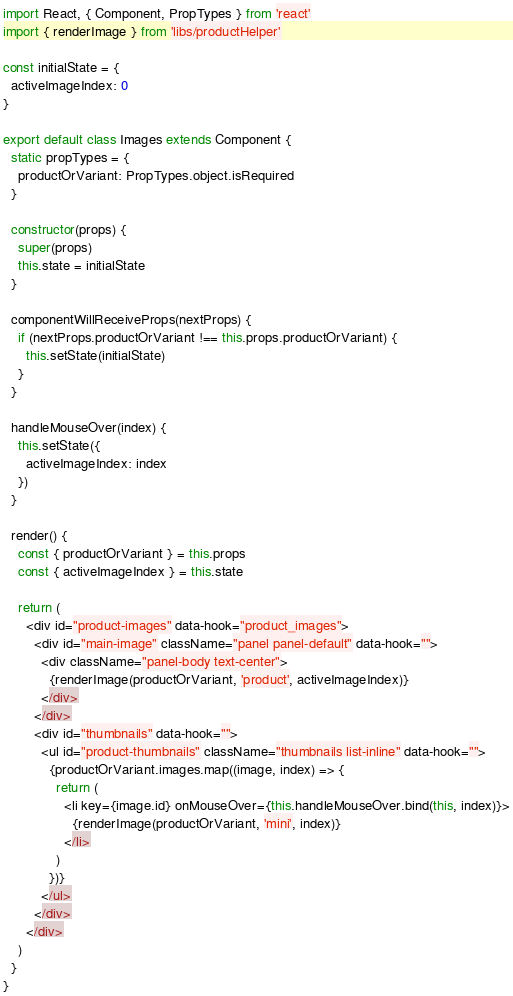<code> <loc_0><loc_0><loc_500><loc_500><_JavaScript_>import React, { Component, PropTypes } from 'react'
import { renderImage } from 'libs/productHelper'

const initialState = {
  activeImageIndex: 0
}

export default class Images extends Component {
  static propTypes = {
    productOrVariant: PropTypes.object.isRequired
  }

  constructor(props) {
    super(props)
    this.state = initialState
  }

  componentWillReceiveProps(nextProps) {
    if (nextProps.productOrVariant !== this.props.productOrVariant) {
      this.setState(initialState)
    }
  }

  handleMouseOver(index) {
    this.setState({
      activeImageIndex: index
    })
  }

  render() {
    const { productOrVariant } = this.props
    const { activeImageIndex } = this.state

    return (
      <div id="product-images" data-hook="product_images">
        <div id="main-image" className="panel panel-default" data-hook="">
          <div className="panel-body text-center">
            {renderImage(productOrVariant, 'product', activeImageIndex)}
          </div>
        </div>
        <div id="thumbnails" data-hook="">
          <ul id="product-thumbnails" className="thumbnails list-inline" data-hook="">
            {productOrVariant.images.map((image, index) => {
              return (
                <li key={image.id} onMouseOver={this.handleMouseOver.bind(this, index)}>
                  {renderImage(productOrVariant, 'mini', index)}
                </li>
              )
            })}
          </ul>
        </div>
      </div>
    )
  }
}
</code> 